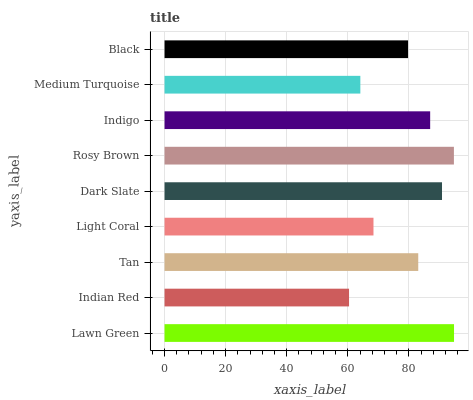Is Indian Red the minimum?
Answer yes or no. Yes. Is Lawn Green the maximum?
Answer yes or no. Yes. Is Tan the minimum?
Answer yes or no. No. Is Tan the maximum?
Answer yes or no. No. Is Tan greater than Indian Red?
Answer yes or no. Yes. Is Indian Red less than Tan?
Answer yes or no. Yes. Is Indian Red greater than Tan?
Answer yes or no. No. Is Tan less than Indian Red?
Answer yes or no. No. Is Tan the high median?
Answer yes or no. Yes. Is Tan the low median?
Answer yes or no. Yes. Is Black the high median?
Answer yes or no. No. Is Rosy Brown the low median?
Answer yes or no. No. 